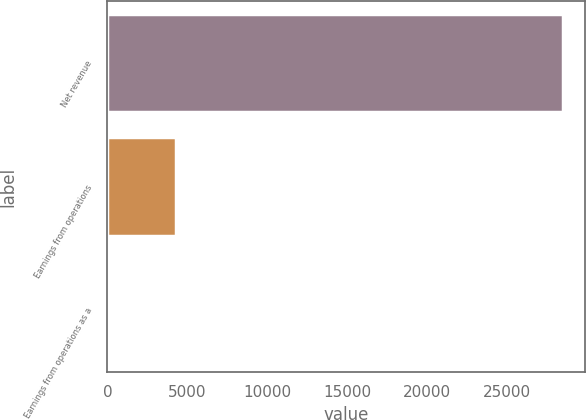<chart> <loc_0><loc_0><loc_500><loc_500><bar_chart><fcel>Net revenue<fcel>Earnings from operations<fcel>Earnings from operations as a<nl><fcel>28465<fcel>4315<fcel>15.2<nl></chart> 